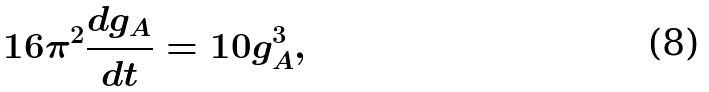Convert formula to latex. <formula><loc_0><loc_0><loc_500><loc_500>1 6 \pi ^ { 2 } \frac { d g _ { A } } { d t } = 1 0 g _ { A } ^ { 3 } ,</formula> 